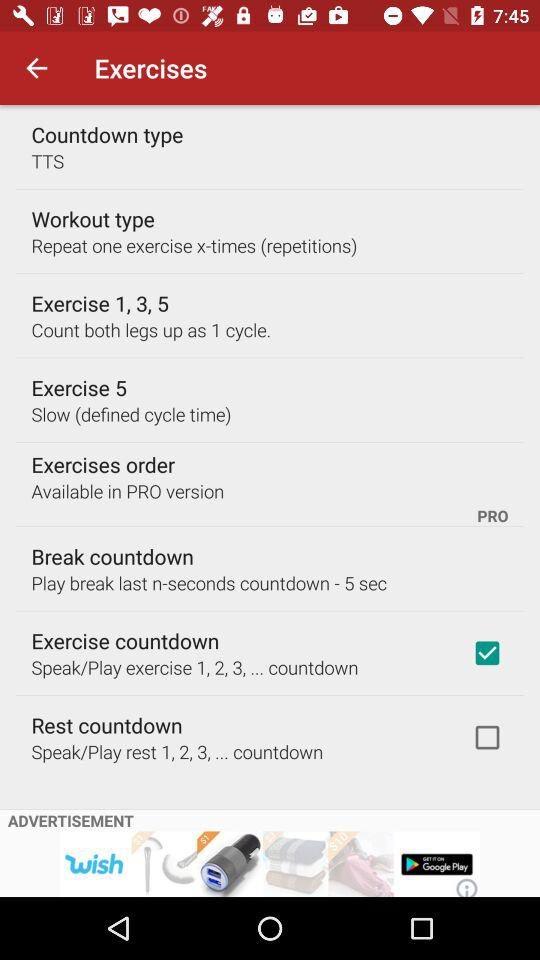What's the status of "Exercise countdown"? The status is "on". 